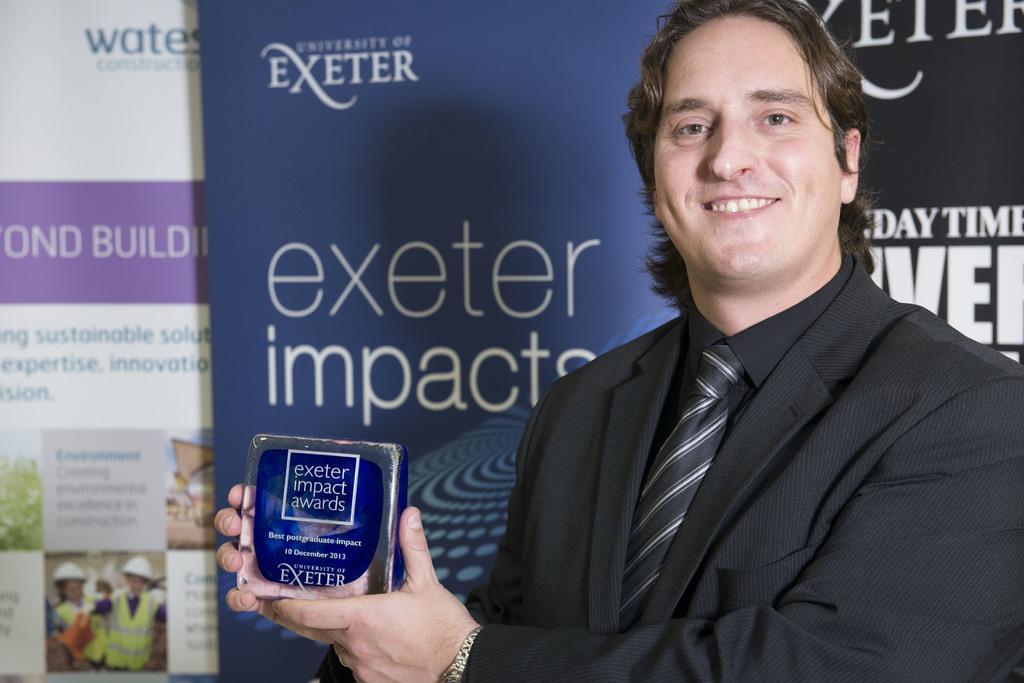In one or two sentences, can you explain what this image depicts? In this image in the foreground there is one person who is holding some box, and in the background there are some boards and on the boards there is some text. 